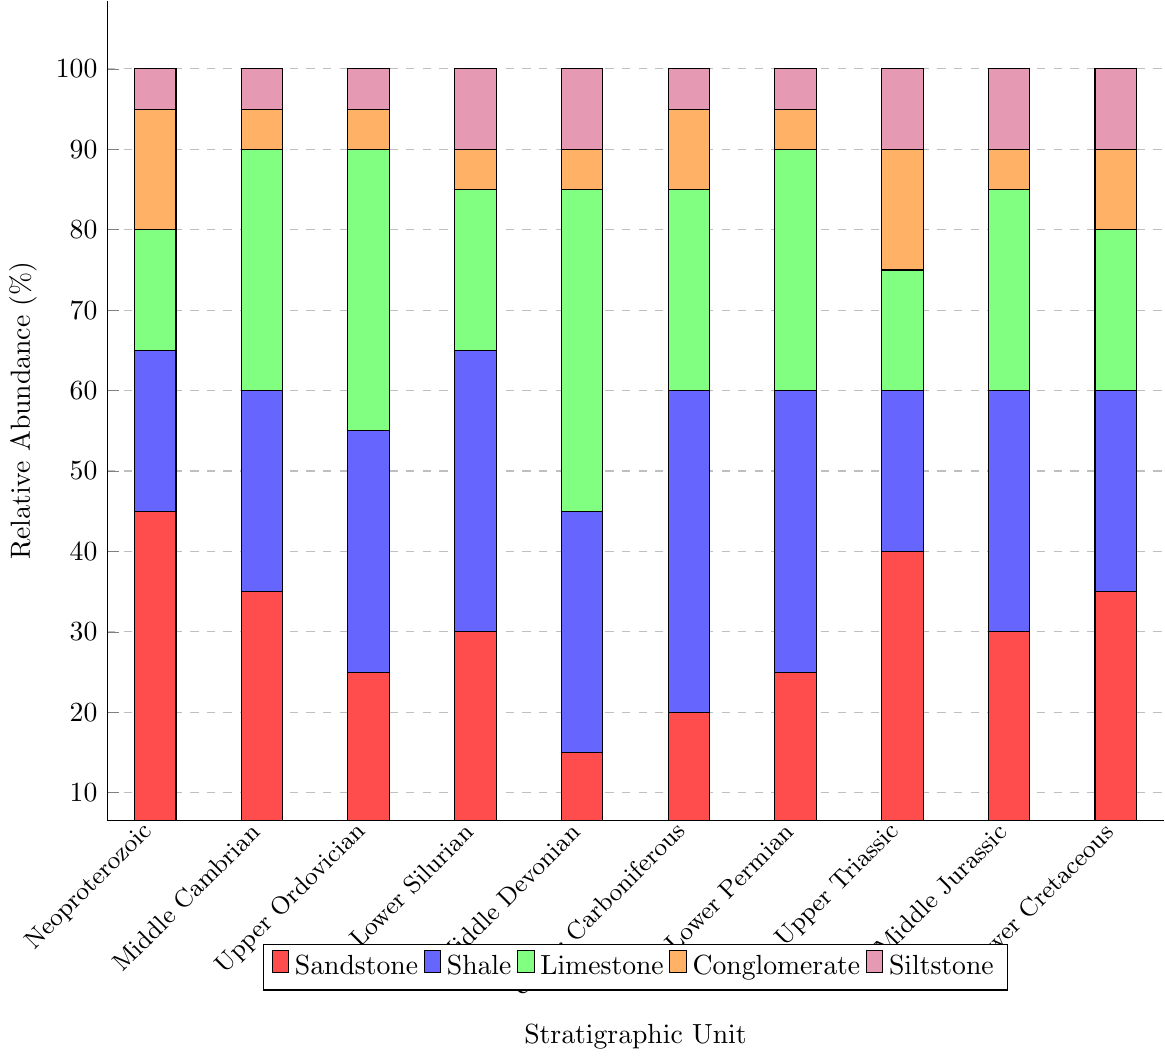What is the most abundant rock type in the Neoproterozoic unit? The highest bar for the Neoproterozoic unit is red, indicating the relative abundance of sandstone is the highest.
Answer: Sandstone Which stratigraphic unit has the highest relative abundance of shale? By visual inspection, the tallest blue bar (shale) is in the Upper Carboniferous unit.
Answer: Upper Carboniferous Compared to the Middle Cambrian unit, which stratigraphic unit has a higher relative abundance of limestone? The relative abundance of limestone in the Middle Cambrian unit is 30%. Units with higher green bars are Middle Devonian (40%) and Upper Ordovician (35%).
Answer: Middle Devonian, Upper Ordovician In which stratigraphic unit is the combined relative abundance of shale and limestone the greatest? Calculate the sum of the blue and green bars for each unit. The highest total is for Middle Devonian (30% shale + 40% limestone = 70%).
Answer: Middle Devonian How does the relative abundance of conglomerate in the Lower Cretaceous unit compare to that in the Upper Triassic unit? The orange bar for conglomerate in the Lower Cretaceous unit (10%) is lower than in the Upper Triassic unit (15%).
Answer: Lower What is the average relative abundance of siltstone across all units? Sum the percentages of siltstone (purple bars) across all units and divide by the number of units. The total is 85%/10 units.
Answer: 8.5% Which unit contains equal relative abundances of sandstone and shale? Look for units where the red and blue bars are equal. Only the Middle Jurassic (30% each for sandstone and shale) fits this criterion.
Answer: Middle Jurassic What is the sum of the sandstone abundance in Neoproterozoic and Middle Cambrian units? Add the red bar values for Neoproterozoic (45%) and Middle Cambrian (35%). 45 + 35 = 80
Answer: 80 Which unit has the least total relative abundance of sandstone and limestone combined? Sum the red and green bars for each unit. The lowest combined total is for Middle Devonian (15% sandstone + 40% limestone = 55%).
Answer: Middle Devonian In the Lower Permian unit, what is the difference between the relative abundance of shale and conglomerate? Subtract the orange bar value (5%) from the blue bar value (35%) in the Lower Permian unit. 35 - 5 = 30
Answer: 30 